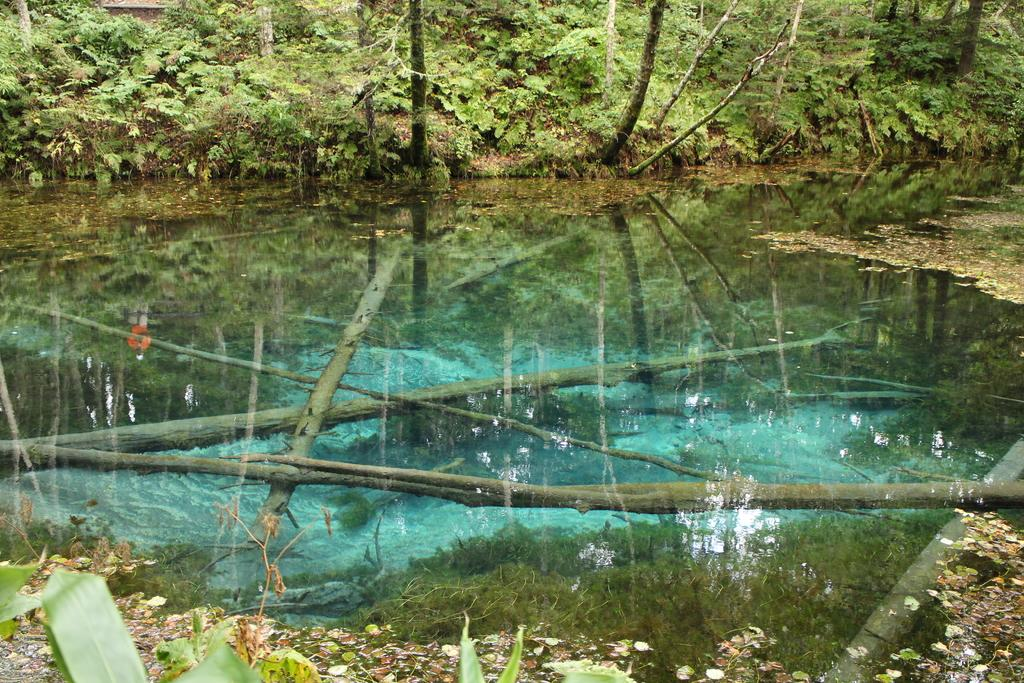What is the main subject in the middle of the picture? There is a pond in the middle of the picture. What can be seen in the background of the picture? There are plants and trees in the background of the picture. Can you see a friend holding a string and a chain in the image? There is no friend, string, or chain present in the image. 